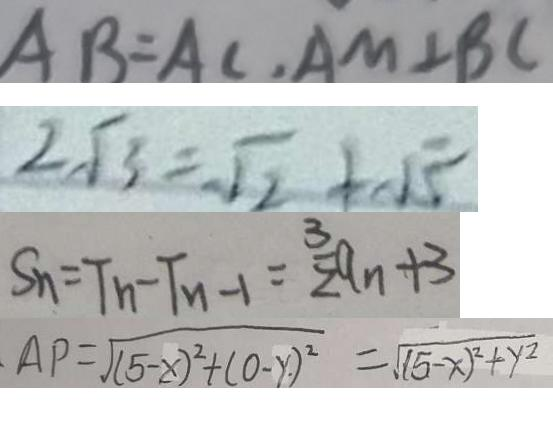<formula> <loc_0><loc_0><loc_500><loc_500>A B = A C , A M \bot B C 
 2 \sqrt { 3 } = \sqrt { 2 } + \sqrt { 5 } 
 S _ { n } = T _ { n } - T _ { n - 1 } = \frac { 3 } { 2 } a _ { n } + 3 
 A P = \sqrt { ( 5 - x ) ^ { 2 } + ( 0 - y ) ^ { 2 } } = \sqrt { ( 5 - x ) ^ { 2 } + y ^ { 2 } }</formula> 